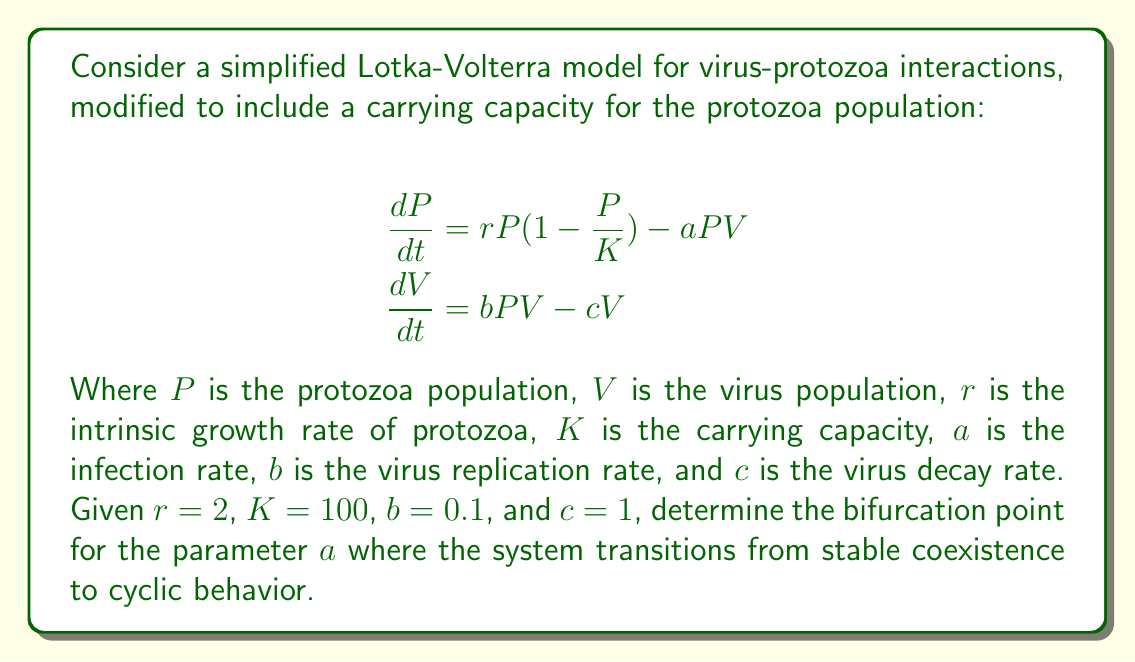What is the answer to this math problem? To find the bifurcation point, we need to analyze the stability of the non-trivial equilibrium point. Let's proceed step-by-step:

1) First, find the non-trivial equilibrium point by setting both equations to zero:

   $$rP(1-\frac{P}{K}) - aPV = 0$$
   $$bPV - cV = 0$$

2) From the second equation, we get $P^* = \frac{c}{b}$ (where $*$ denotes equilibrium values).

3) Substituting this into the first equation:

   $$r\frac{c}{b}(1-\frac{c}{bK}) - aV^* \frac{c}{b} = 0$$

4) Solving for $V^*$:

   $$V^* = \frac{r}{a}(1-\frac{c}{bK})$$

5) The Jacobian matrix at the equilibrium point is:

   $$J = \begin{bmatrix}
   r(1-\frac{2P^*}{K}) - aV^* & -aP^* \\
   bV^* & bP^* - c
   \end{bmatrix}$$

6) Substituting the equilibrium values:

   $$J = \begin{bmatrix}
   r(1-\frac{2c}{bK}) - r(1-\frac{c}{bK}) & -ac/b \\
   r(1-\frac{c}{bK}) & 0
   \end{bmatrix}$$

7) The characteristic equation is:

   $$\lambda^2 - \text{tr}(J)\lambda + \det(J) = 0$$

   where $\text{tr}(J)$ is the trace and $\det(J)$ is the determinant of $J$.

8) The bifurcation occurs when the real part of the eigenvalues becomes zero, which happens when $\text{tr}(J) = 0$:

   $$r(1-\frac{2c}{bK}) - r(1-\frac{c}{bK}) = 0$$

9) Simplifying:

   $$-\frac{rc}{bK} = 0$$

10) This is always true for non-zero parameters, so we need to look at the next condition: $\det(J) > 0$ for stability.

11) $\det(J) = \frac{arc}{b}(1-\frac{c}{bK})$

12) Setting this greater than zero:

    $$a > \frac{b}{r(1-\frac{c}{bK})}$$

13) Substituting the given values:

    $$a > \frac{0.1}{2(1-\frac{1}{0.1 * 100})} = 0.0526$$

Therefore, the bifurcation point occurs at $a \approx 0.0526$.
Answer: $a \approx 0.0526$ 